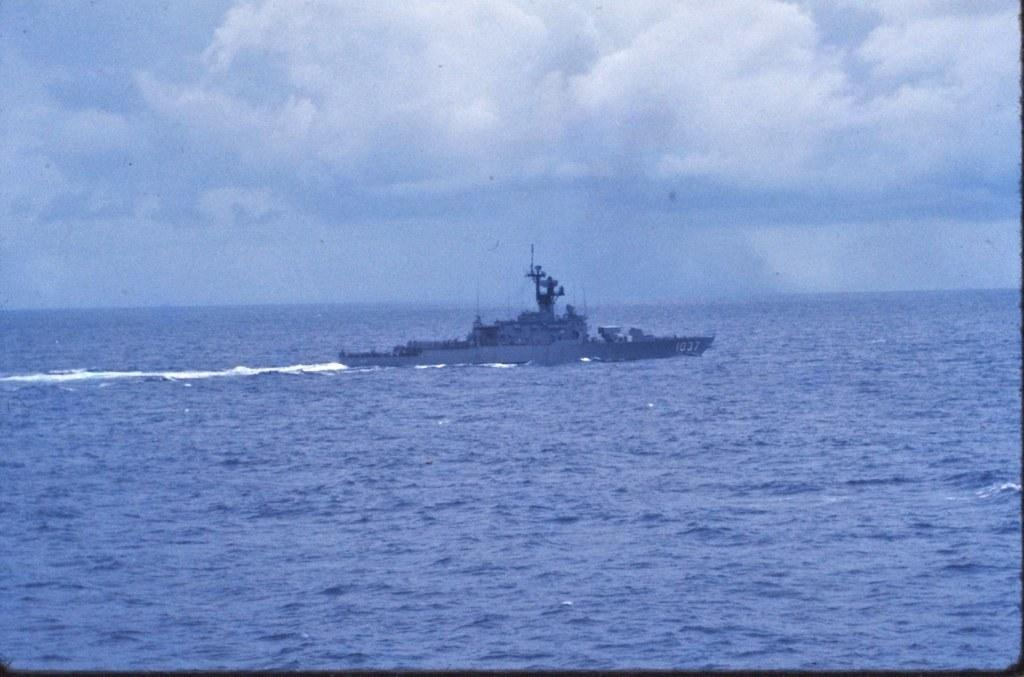What can be seen in the background of the image? The sky with clouds is visible in the background of the image. What is the main subject of the image? There is a navy ship in the image. What type of environment is depicted in the image? There is water visible in the image, suggesting a maritime setting. What color is the rose on the deck of the navy ship in the image? There is no rose present on the deck of the navy ship in the image. 